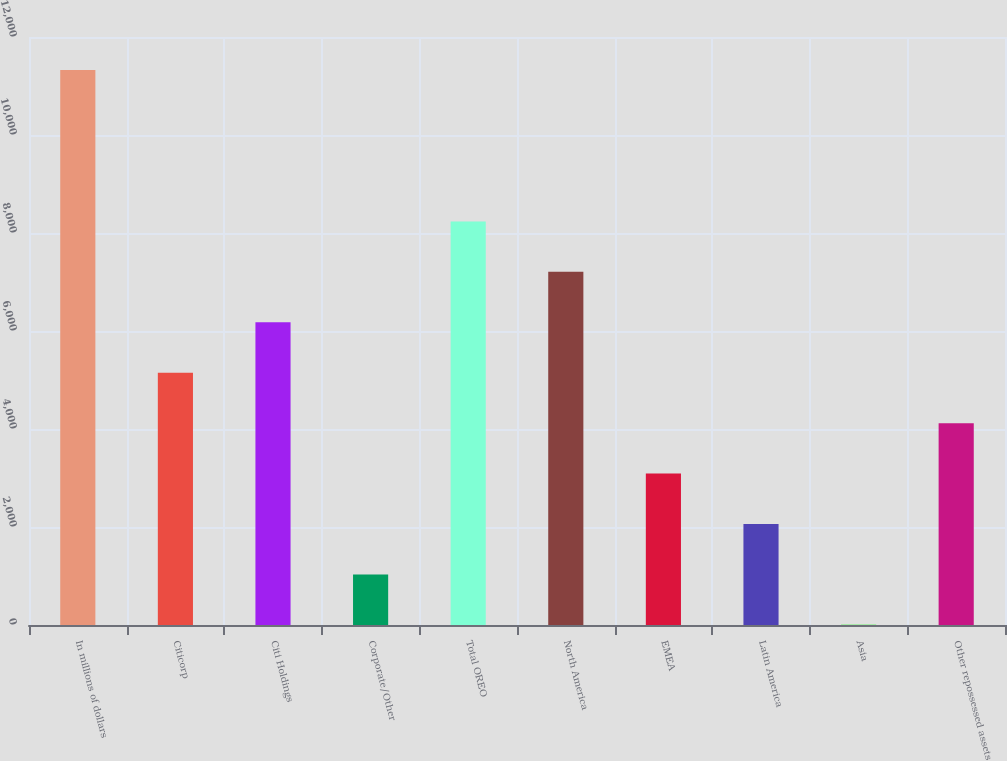Convert chart to OTSL. <chart><loc_0><loc_0><loc_500><loc_500><bar_chart><fcel>In millions of dollars<fcel>Citicorp<fcel>Citi Holdings<fcel>Corporate/Other<fcel>Total OREO<fcel>North America<fcel>EMEA<fcel>Latin America<fcel>Asia<fcel>Other repossessed assets<nl><fcel>11324.2<fcel>5149<fcel>6178.2<fcel>1032.2<fcel>8236.6<fcel>7207.4<fcel>3090.6<fcel>2061.4<fcel>3<fcel>4119.8<nl></chart> 